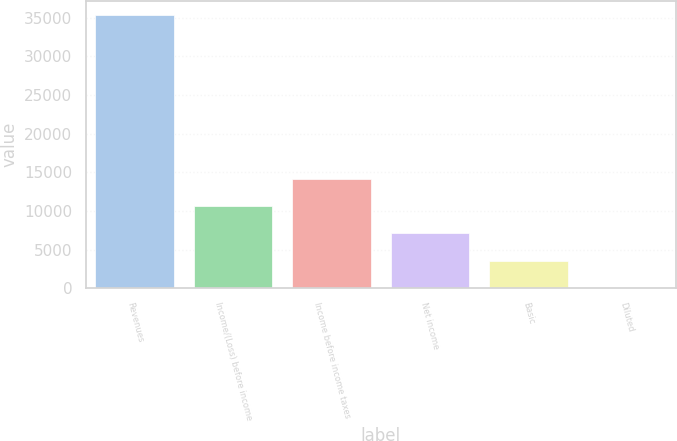Convert chart. <chart><loc_0><loc_0><loc_500><loc_500><bar_chart><fcel>Revenues<fcel>Income/(Loss) before income<fcel>Income before income taxes<fcel>Net income<fcel>Basic<fcel>Diluted<nl><fcel>35365<fcel>10609.7<fcel>14146.2<fcel>7073.26<fcel>3536.79<fcel>0.32<nl></chart> 